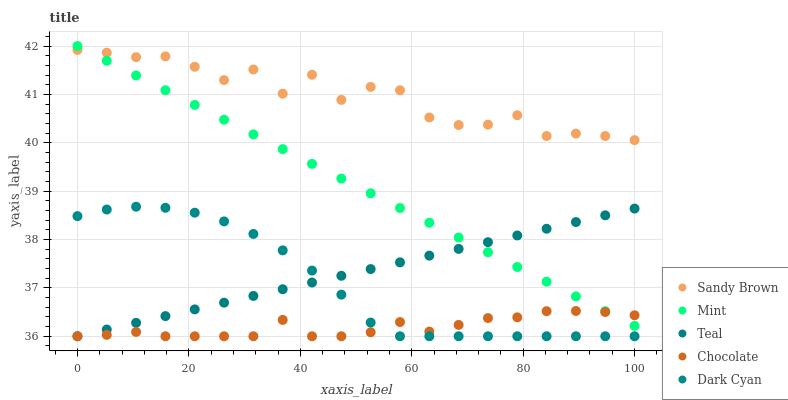Does Chocolate have the minimum area under the curve?
Answer yes or no. Yes. Does Sandy Brown have the maximum area under the curve?
Answer yes or no. Yes. Does Mint have the minimum area under the curve?
Answer yes or no. No. Does Mint have the maximum area under the curve?
Answer yes or no. No. Is Teal the smoothest?
Answer yes or no. Yes. Is Sandy Brown the roughest?
Answer yes or no. Yes. Is Mint the smoothest?
Answer yes or no. No. Is Mint the roughest?
Answer yes or no. No. Does Dark Cyan have the lowest value?
Answer yes or no. Yes. Does Mint have the lowest value?
Answer yes or no. No. Does Mint have the highest value?
Answer yes or no. Yes. Does Sandy Brown have the highest value?
Answer yes or no. No. Is Chocolate less than Sandy Brown?
Answer yes or no. Yes. Is Mint greater than Dark Cyan?
Answer yes or no. Yes. Does Mint intersect Teal?
Answer yes or no. Yes. Is Mint less than Teal?
Answer yes or no. No. Is Mint greater than Teal?
Answer yes or no. No. Does Chocolate intersect Sandy Brown?
Answer yes or no. No. 